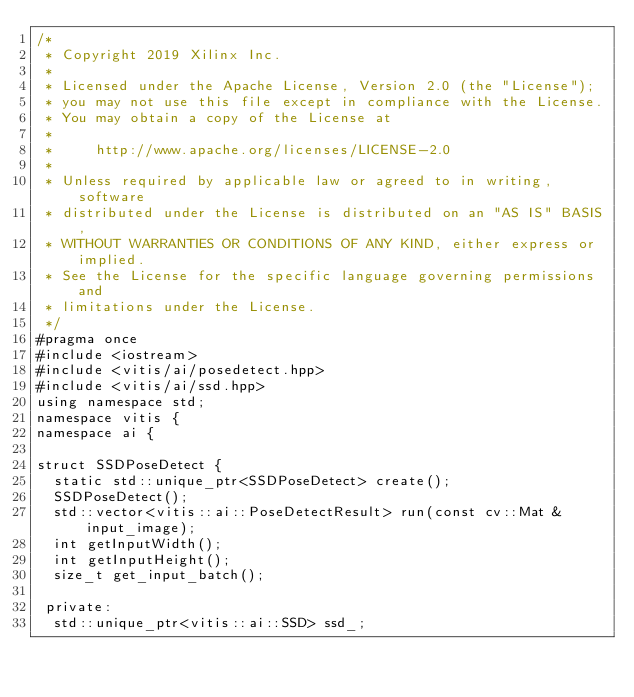Convert code to text. <code><loc_0><loc_0><loc_500><loc_500><_C++_>/*
 * Copyright 2019 Xilinx Inc.
 *
 * Licensed under the Apache License, Version 2.0 (the "License");
 * you may not use this file except in compliance with the License.
 * You may obtain a copy of the License at
 *
 *     http://www.apache.org/licenses/LICENSE-2.0
 *
 * Unless required by applicable law or agreed to in writing, software
 * distributed under the License is distributed on an "AS IS" BASIS,
 * WITHOUT WARRANTIES OR CONDITIONS OF ANY KIND, either express or implied.
 * See the License for the specific language governing permissions and
 * limitations under the License.
 */
#pragma once
#include <iostream>
#include <vitis/ai/posedetect.hpp>
#include <vitis/ai/ssd.hpp>
using namespace std;
namespace vitis {
namespace ai {

struct SSDPoseDetect {
  static std::unique_ptr<SSDPoseDetect> create();
  SSDPoseDetect();
  std::vector<vitis::ai::PoseDetectResult> run(const cv::Mat &input_image);
  int getInputWidth();
  int getInputHeight();
  size_t get_input_batch();

 private:
  std::unique_ptr<vitis::ai::SSD> ssd_;</code> 